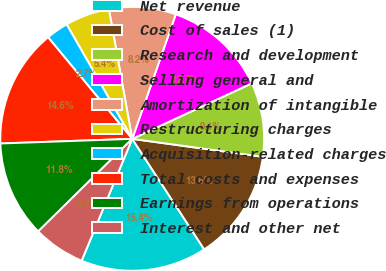Convert chart. <chart><loc_0><loc_0><loc_500><loc_500><pie_chart><fcel>Net revenue<fcel>Cost of sales (1)<fcel>Research and development<fcel>Selling general and<fcel>Amortization of intangible<fcel>Restructuring charges<fcel>Acquisition-related charges<fcel>Total costs and expenses<fcel>Earnings from operations<fcel>Interest and other net<nl><fcel>15.45%<fcel>13.64%<fcel>9.09%<fcel>12.73%<fcel>8.18%<fcel>5.45%<fcel>2.73%<fcel>14.55%<fcel>11.82%<fcel>6.36%<nl></chart> 